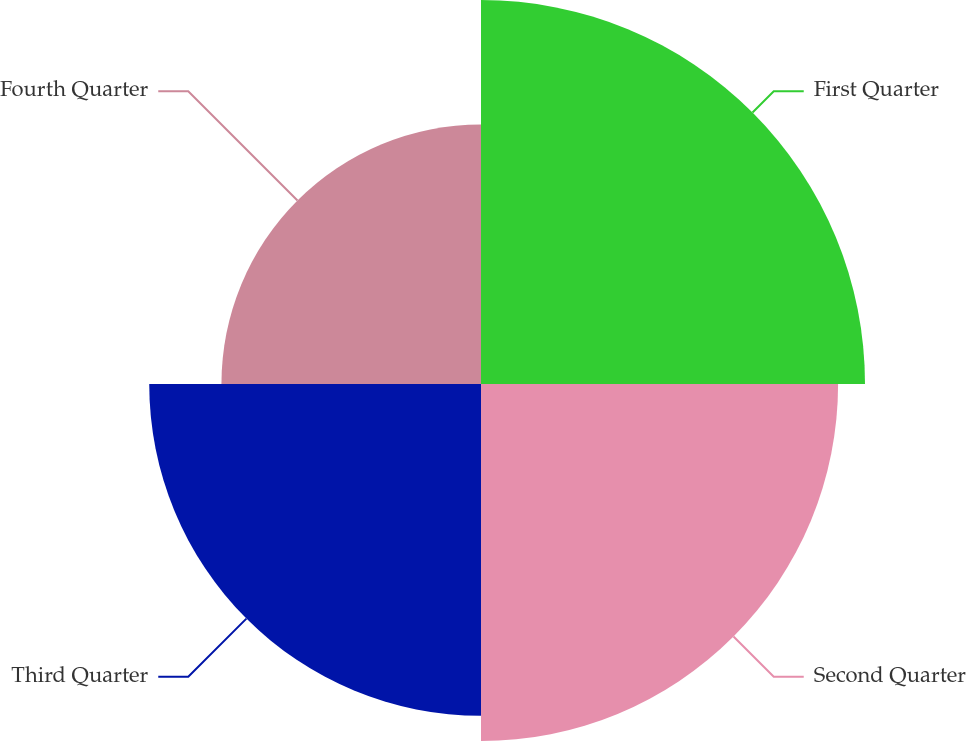Convert chart to OTSL. <chart><loc_0><loc_0><loc_500><loc_500><pie_chart><fcel>First Quarter<fcel>Second Quarter<fcel>Third Quarter<fcel>Fourth Quarter<nl><fcel>28.82%<fcel>26.8%<fcel>24.9%<fcel>19.48%<nl></chart> 